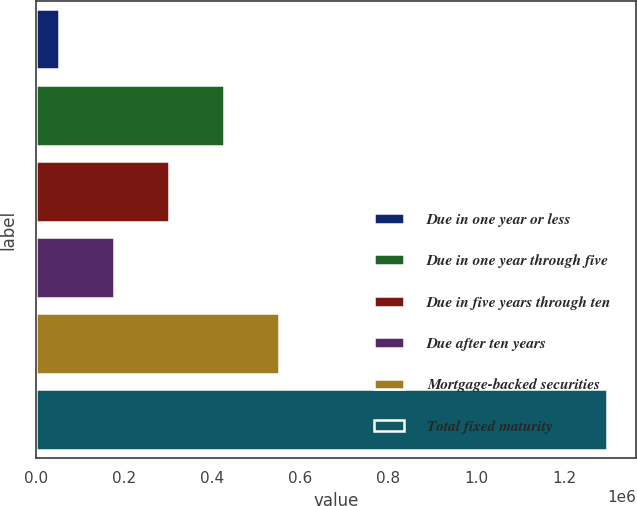Convert chart. <chart><loc_0><loc_0><loc_500><loc_500><bar_chart><fcel>Due in one year or less<fcel>Due in one year through five<fcel>Due in five years through ten<fcel>Due after ten years<fcel>Mortgage-backed securities<fcel>Total fixed maturity<nl><fcel>52086<fcel>425939<fcel>301321<fcel>176704<fcel>550556<fcel>1.29826e+06<nl></chart> 